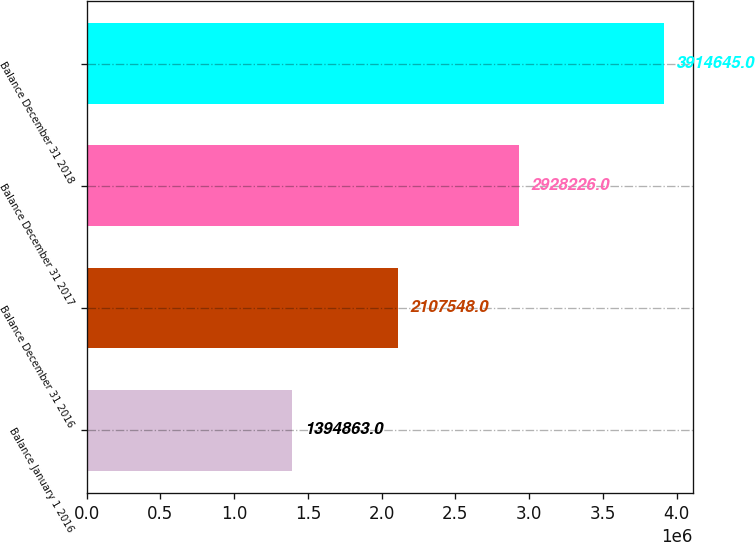<chart> <loc_0><loc_0><loc_500><loc_500><bar_chart><fcel>Balance January 1 2016<fcel>Balance December 31 2016<fcel>Balance December 31 2017<fcel>Balance December 31 2018<nl><fcel>1.39486e+06<fcel>2.10755e+06<fcel>2.92823e+06<fcel>3.91464e+06<nl></chart> 